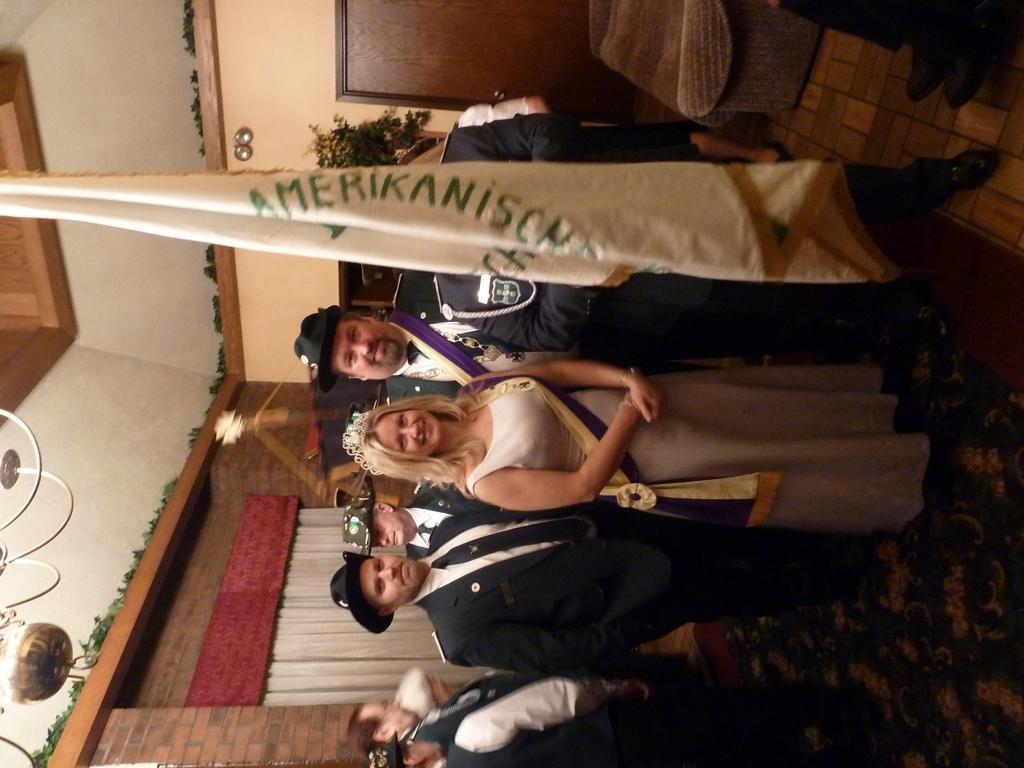Could you give a brief overview of what you see in this image? In the image there are few people standing on the floor. In front of them there is a flag. At the top of the image there is a sofa chair. Behind that there is a wall with door. And in the background there is a wall with curtains and there are some other things 